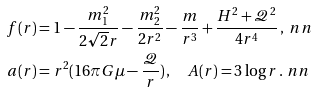Convert formula to latex. <formula><loc_0><loc_0><loc_500><loc_500>f ( r ) & = 1 - \frac { m _ { 1 } ^ { 2 } } { 2 \sqrt { 2 } r } - \frac { m _ { 2 } ^ { 2 } } { 2 r ^ { 2 } } - \frac { m } { r ^ { 3 } } + \frac { H ^ { 2 } + \mathcal { Q } ^ { 2 } } { 4 r ^ { 4 } } \, , \ n n \\ a ( r ) & = r ^ { 2 } ( 1 6 \pi G \mu - \frac { \mathcal { Q } } { r } ) \, , \quad A ( r ) = 3 \log r \, . \ n n</formula> 